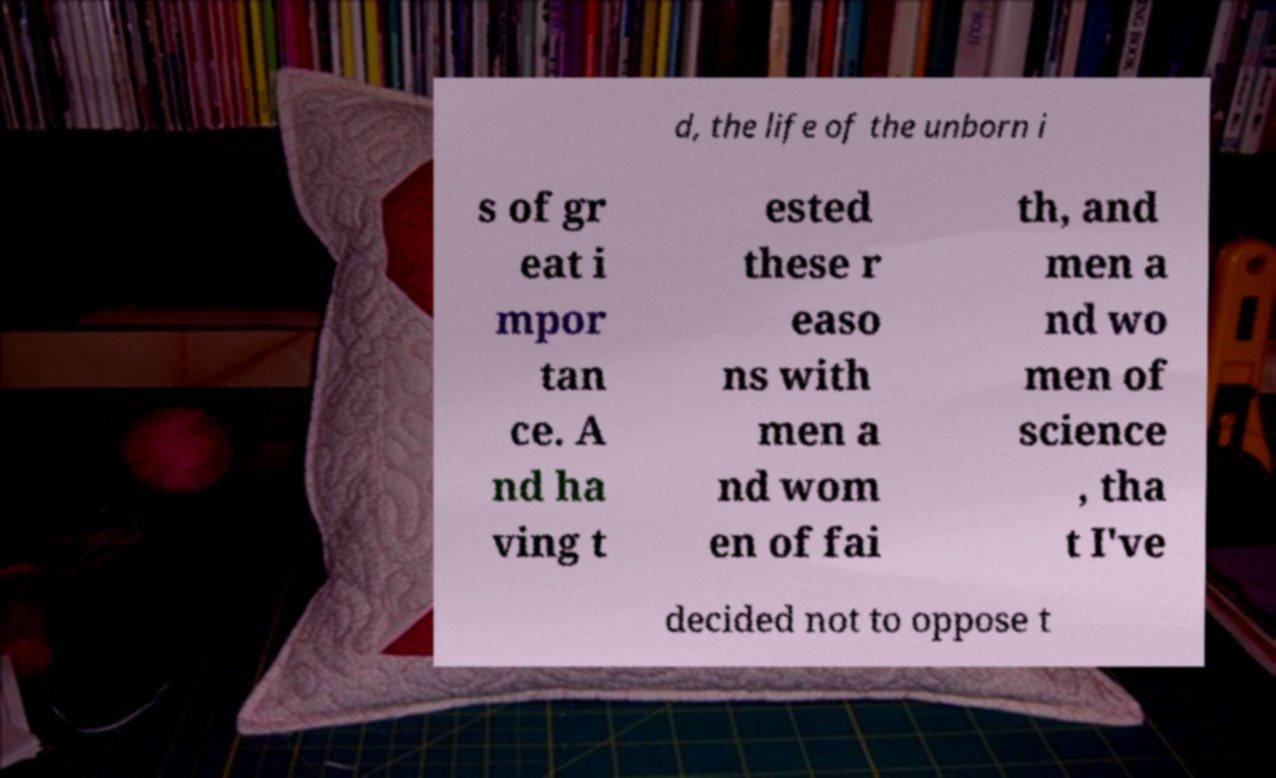I need the written content from this picture converted into text. Can you do that? d, the life of the unborn i s of gr eat i mpor tan ce. A nd ha ving t ested these r easo ns with men a nd wom en of fai th, and men a nd wo men of science , tha t I've decided not to oppose t 